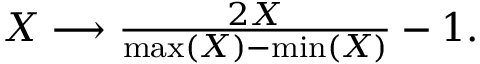Convert formula to latex. <formula><loc_0><loc_0><loc_500><loc_500>\begin{array} { r } { X \longrightarrow \frac { 2 X } { \max ( X ) - \min ( X ) } - 1 . } \end{array}</formula> 